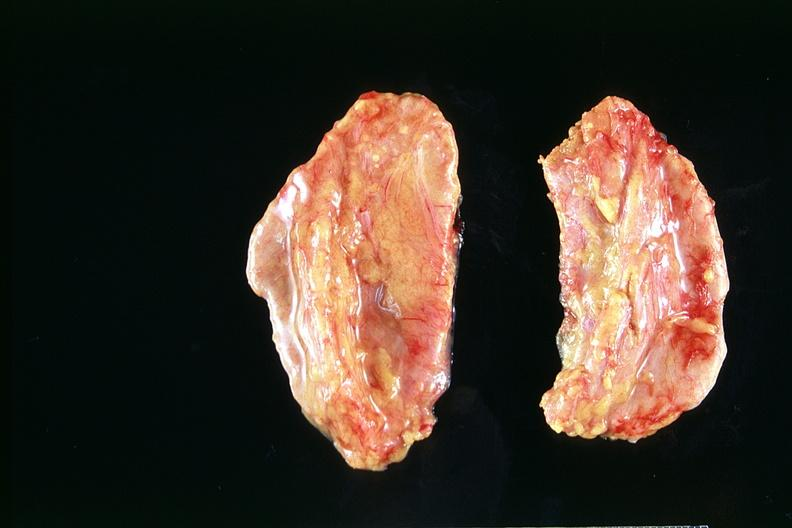s endocrine present?
Answer the question using a single word or phrase. Yes 